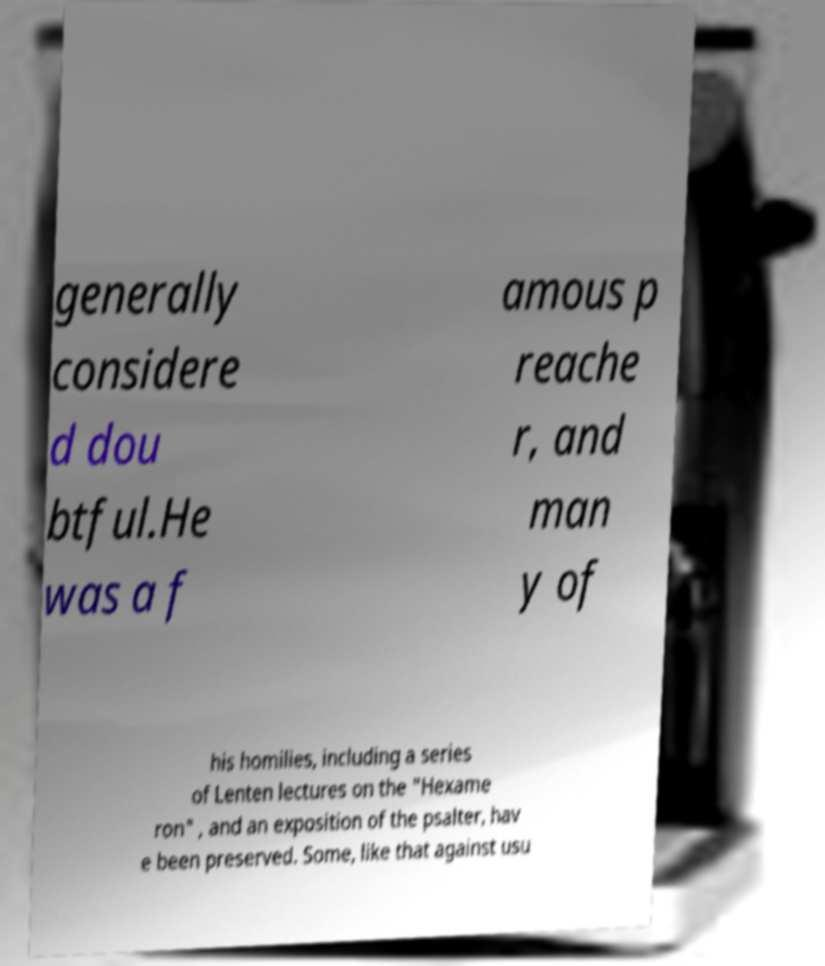What messages or text are displayed in this image? I need them in a readable, typed format. generally considere d dou btful.He was a f amous p reache r, and man y of his homilies, including a series of Lenten lectures on the "Hexame ron" , and an exposition of the psalter, hav e been preserved. Some, like that against usu 